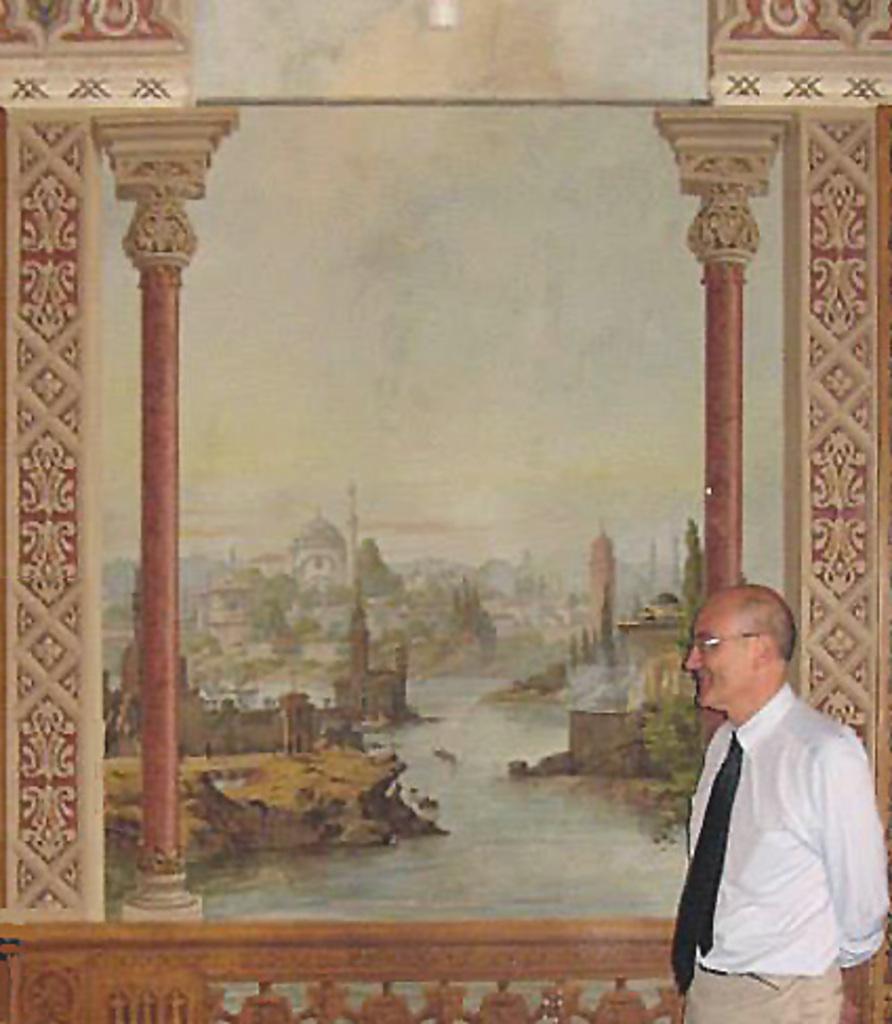How would you summarize this image in a sentence or two? Here in this picture we can see an old man looking at a painting. The old man is wearing a white shirt ,black tie and a cream colored pant. The painting has a castle and a river in it. 